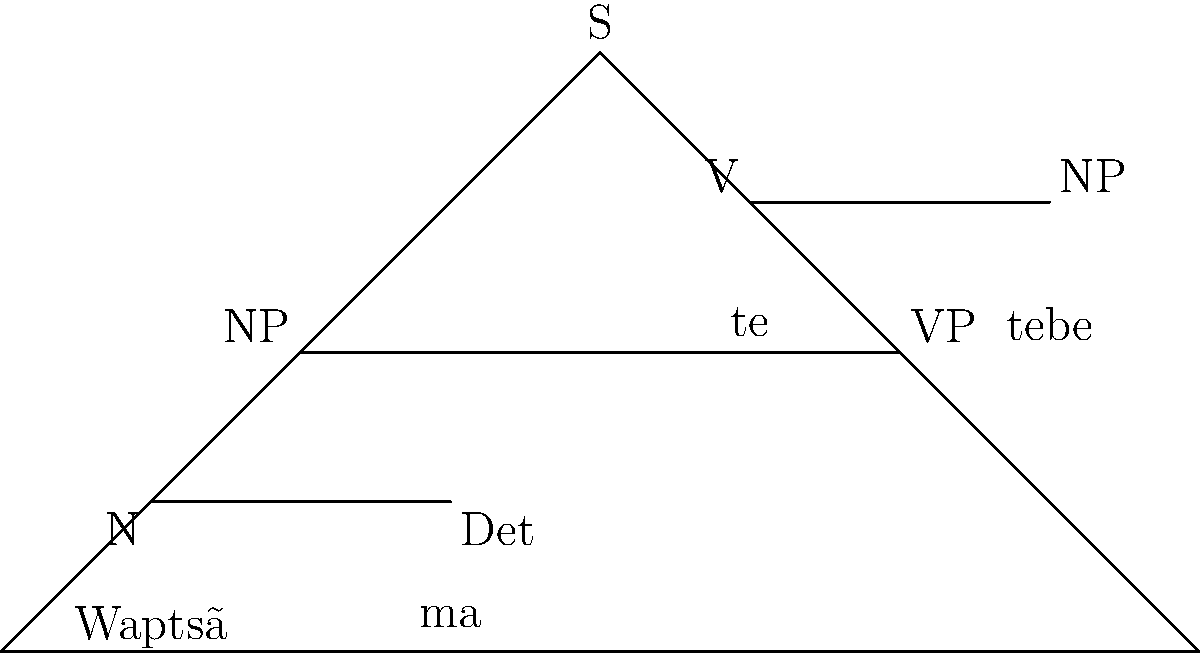Analyze the syntactic structure of the Xavante sentence "Waptsã ma te tebe" using the provided tree diagram. What is the correct order of constituents in this sentence, and how does it differ from English sentence structure? To analyze the syntactic structure of the Xavante sentence "Waptsã ma te tebe" using the provided tree diagram, let's follow these steps:

1. Identify the main constituents:
   - S (Sentence) is at the top of the tree
   - NP (Noun Phrase) is on the left branch
   - VP (Verb Phrase) is on the right branch

2. Analyze the NP (Noun Phrase):
   - It consists of two elements: N (Noun) and Det (Determiner)
   - The noun "Waptsã" (dog) comes before the determiner "ma" (a/the)

3. Analyze the VP (Verb Phrase):
   - It consists of two elements: V (Verb) and NP (Noun Phrase)
   - The verb "te" (bit) comes before the object NP "tebe" (you)

4. Compare the structure to English:
   - Xavante order: Subject (NP) + Verb + Object (NP)
   - English order: Subject (NP) + Verb + Object (NP)

5. Note the differences:
   - In Xavante, the determiner comes after the noun, unlike in English
   - The basic SVO (Subject-Verb-Object) structure is similar to English

The correct order of constituents in this Xavante sentence is:
Noun + Determiner + Verb + Object

This differs from English in the placement of the determiner, which would typically come before the noun in English (e.g., "The dog bit you" instead of "Dog the bit you").
Answer: Noun + Determiner + Verb + Object, with post-nominal determiners 